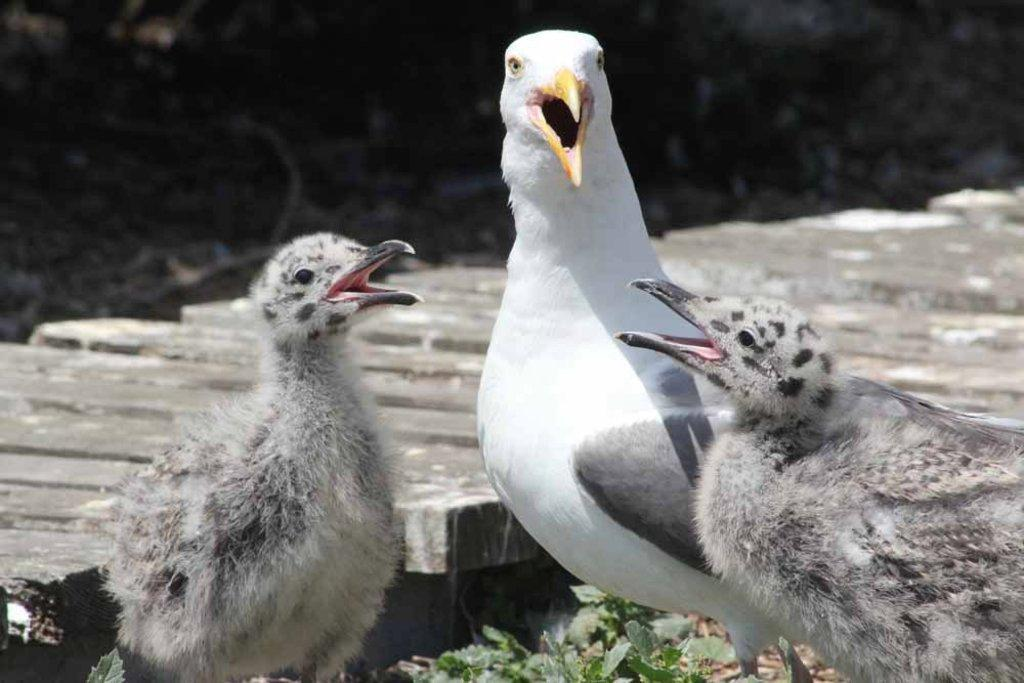What type of animals can be seen in the image? Birds can be seen in the image. What other living organisms are present in the image? There are plants in the image. How many cars can be seen in the image? There are no cars present in the image; it features birds and plants. What type of bear can be seen interacting with the plants in the image? There is no bear present in the image; it only features birds and plants. 